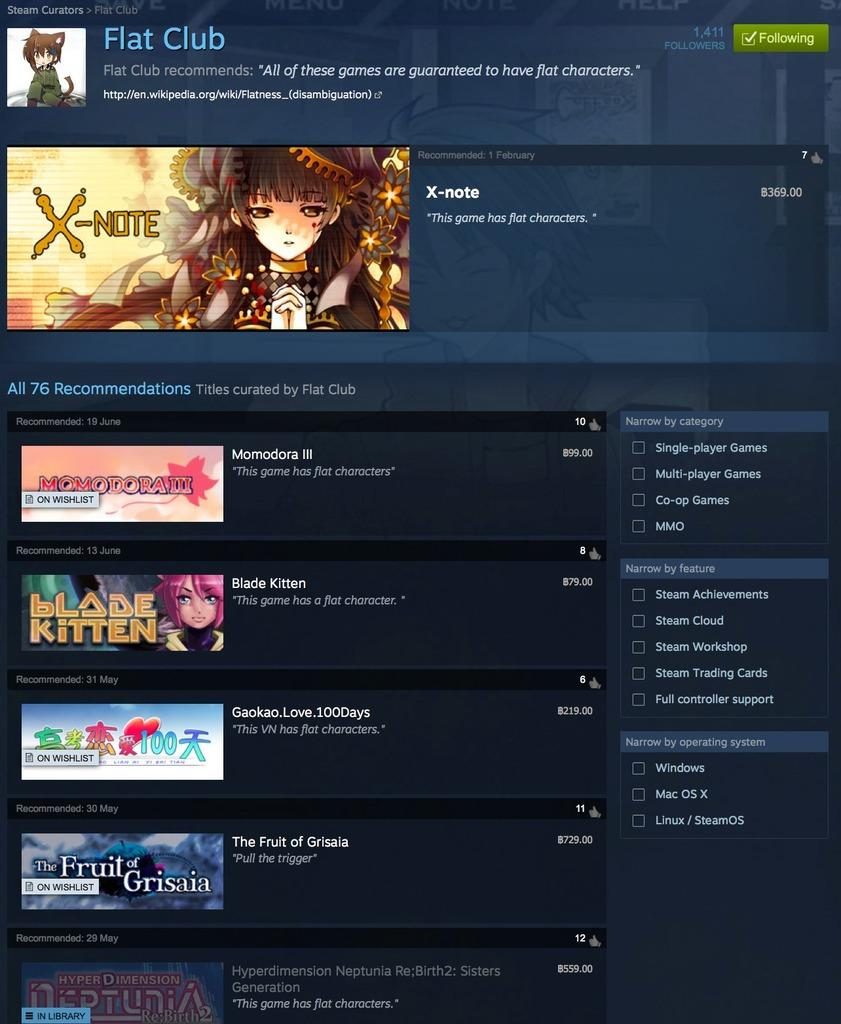What is the main feature of the image? There is a screen in the image. What can be seen on the screen? The screen contains text and animated images. What color is the text on the screen? The text on the screen is in white color. What are the dominant colors of the screen? The screen has a blue and black color scheme. What type of bell can be heard ringing in the image? There is no bell present in the image, and therefore no sound can be heard. 